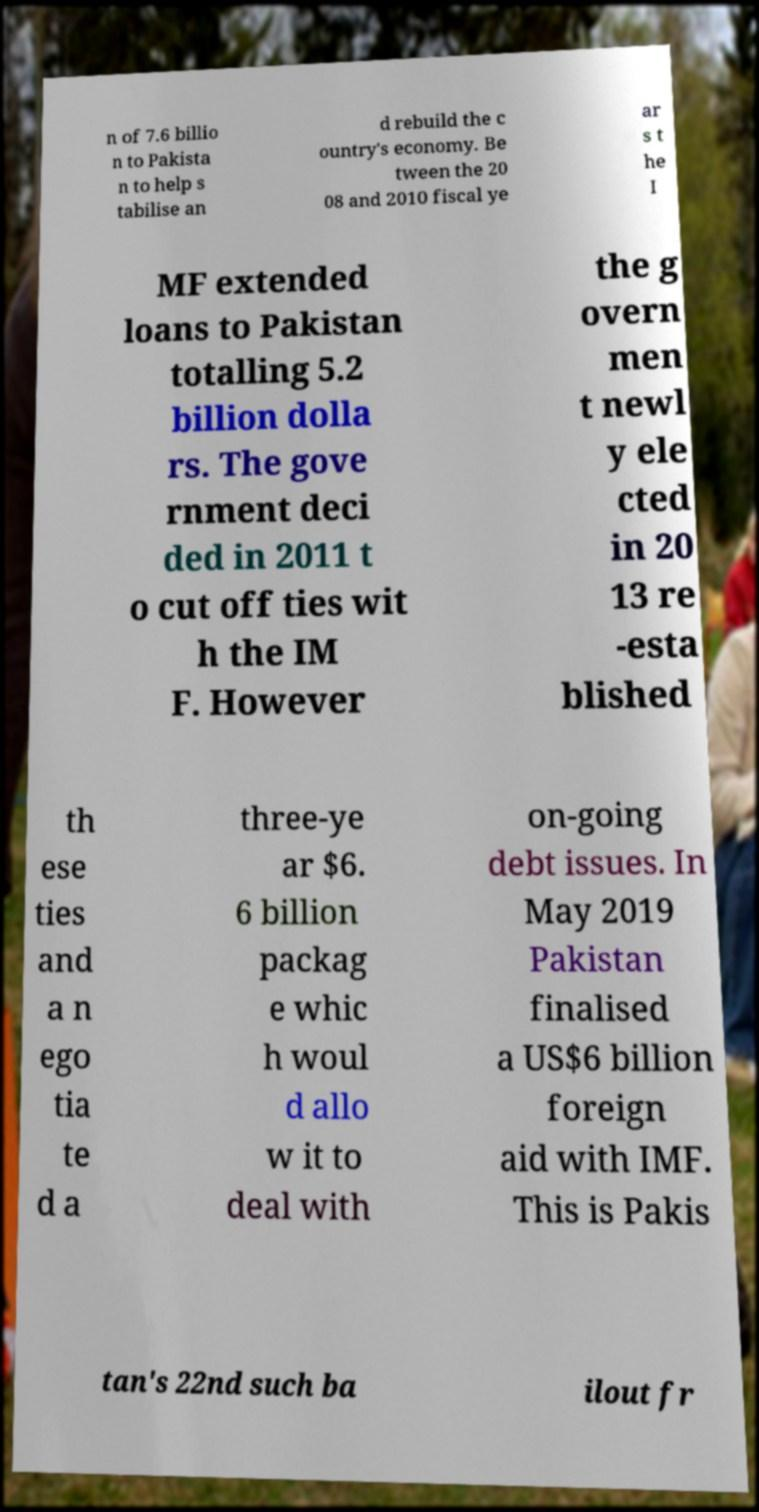Can you accurately transcribe the text from the provided image for me? n of 7.6 billio n to Pakista n to help s tabilise an d rebuild the c ountry's economy. Be tween the 20 08 and 2010 fiscal ye ar s t he I MF extended loans to Pakistan totalling 5.2 billion dolla rs. The gove rnment deci ded in 2011 t o cut off ties wit h the IM F. However the g overn men t newl y ele cted in 20 13 re -esta blished th ese ties and a n ego tia te d a three-ye ar $6. 6 billion packag e whic h woul d allo w it to deal with on-going debt issues. In May 2019 Pakistan finalised a US$6 billion foreign aid with IMF. This is Pakis tan's 22nd such ba ilout fr 